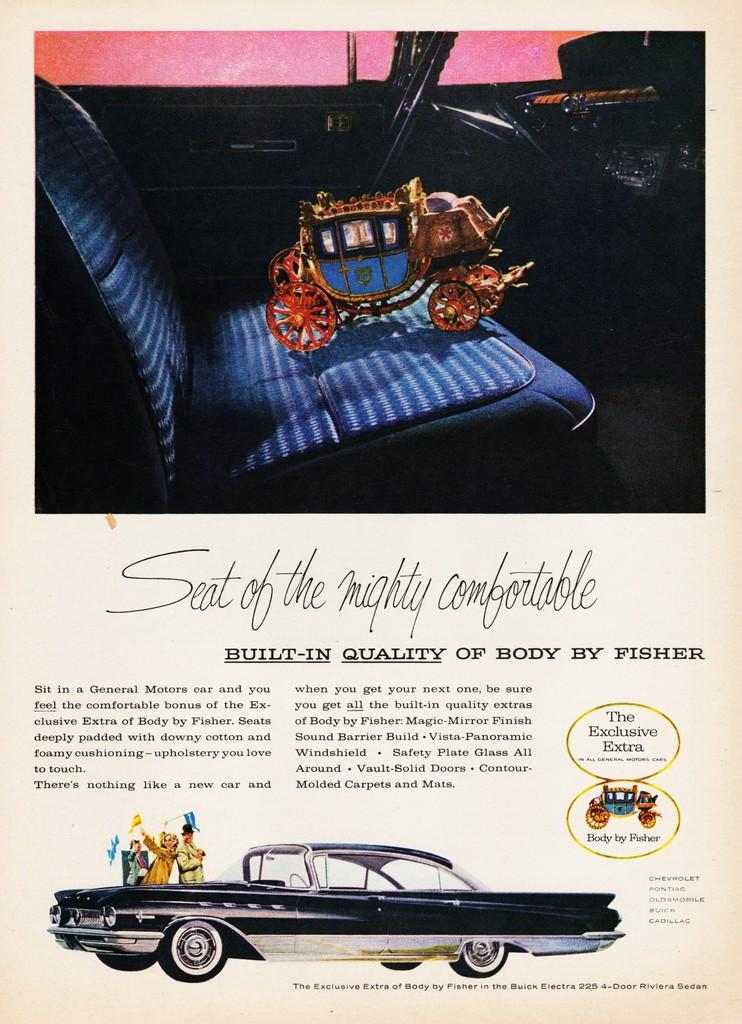What is present in the image that contains images and text? There is a poster in the image that contains images and text. What types of subjects are depicted on the poster? The poster contains images of people and vehicles. Can you describe the content of the poster? The poster contains images and text, with people and vehicles being the main subjects depicted. What level of difficulty is the spoon depicted on the poster? There is no spoon present on the poster, so it is not possible to determine its level of difficulty. 